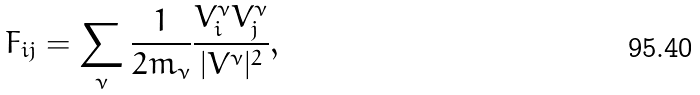<formula> <loc_0><loc_0><loc_500><loc_500>F _ { i j } = \sum _ { \nu } \frac { 1 } { 2 m _ { \nu } } { \frac { V ^ { \nu } _ { i } V ^ { \nu } _ { j } } { | V ^ { \nu } | ^ { 2 } } } ,</formula> 